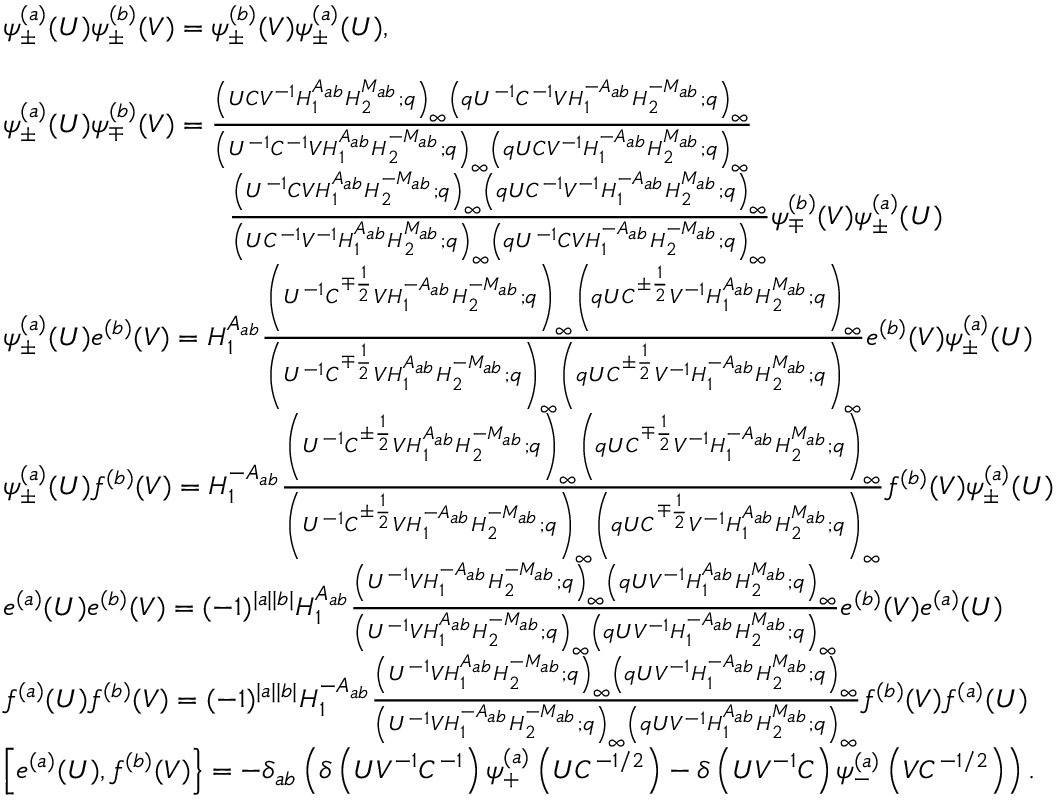Convert formula to latex. <formula><loc_0><loc_0><loc_500><loc_500>\begin{array} { r l } & { \psi _ { \pm } ^ { ( a ) } ( U ) \psi _ { \pm } ^ { ( b ) } ( V ) = \psi _ { \pm } ^ { ( b ) } ( V ) \psi _ { \pm } ^ { ( a ) } ( U ) , } \\ \\ & { \psi _ { \pm } ^ { ( a ) } ( U ) \psi _ { \mp } ^ { ( b ) } ( V ) = \frac { \left ( U C V ^ { - 1 } H _ { 1 } ^ { A _ { a b } } H _ { 2 } ^ { M _ { a b } } ; q \right ) _ { \infty } \left ( q U ^ { - 1 } C ^ { - 1 } V H _ { 1 } ^ { - A _ { a b } } H _ { 2 } ^ { - M _ { a b } } ; q \right ) _ { \infty } } { \left ( U ^ { - 1 } C ^ { - 1 } V H _ { 1 } ^ { A _ { a b } } H _ { 2 } ^ { - M _ { a b } } ; q \right ) _ { \infty } \left ( q U C V ^ { - 1 } H _ { 1 } ^ { - A _ { a b } } H _ { 2 } ^ { M _ { a b } } ; q \right ) _ { \infty } } } \\ & { \quad \frac { \left ( U ^ { - 1 } C V H _ { 1 } ^ { A _ { a b } } H _ { 2 } ^ { - M _ { a b } } ; q \right ) _ { \infty } \left ( q U C ^ { - 1 } V ^ { - 1 } H _ { 1 } ^ { - A _ { a b } } H _ { 2 } ^ { M _ { a b } } ; q \right ) _ { \infty } } { \left ( U C ^ { - 1 } V ^ { - 1 } H _ { 1 } ^ { A _ { a b } } H _ { 2 } ^ { M _ { a b } } ; q \right ) _ { \infty } \left ( q U ^ { - 1 } C V H _ { 1 } ^ { - A _ { a b } } H _ { 2 } ^ { - M _ { a b } } ; q \right ) _ { \infty } } \psi _ { \mp } ^ { ( b ) } ( V ) \psi _ { \pm } ^ { ( a ) } ( U ) } \\ & { \psi _ { \pm } ^ { ( a ) } ( U ) e ^ { ( b ) } ( V ) = H _ { 1 } ^ { A _ { a b } } \frac { \left ( U ^ { - 1 } C ^ { \mp \frac { 1 } { 2 } } V H _ { 1 } ^ { - A _ { a b } } H _ { 2 } ^ { - M _ { a b } } ; q \right ) _ { \infty } \left ( q U C ^ { \pm \frac { 1 } { 2 } } V ^ { - 1 } H _ { 1 } ^ { A _ { a b } } H _ { 2 } ^ { M _ { a b } } ; q \right ) _ { \infty } } { \left ( U ^ { - 1 } C ^ { \mp \frac { 1 } { 2 } } V H _ { 1 } ^ { A _ { a b } } H _ { 2 } ^ { - M _ { a b } } ; q \right ) _ { \infty } \left ( q U C ^ { \pm \frac { 1 } { 2 } } V ^ { - 1 } H _ { 1 } ^ { - A _ { a b } } H _ { 2 } ^ { M _ { a b } } ; q \right ) _ { \infty } } e ^ { ( b ) } ( V ) \psi _ { \pm } ^ { ( a ) } ( U ) } \\ & { \psi _ { \pm } ^ { ( a ) } ( U ) f ^ { ( b ) } ( V ) = H _ { 1 } ^ { - A _ { a b } } \frac { \left ( U ^ { - 1 } C ^ { \pm \frac { 1 } { 2 } } V H _ { 1 } ^ { A _ { a b } } H _ { 2 } ^ { - M _ { a b } } ; q \right ) _ { \infty } \left ( q U C ^ { \mp \frac { 1 } { 2 } } V ^ { - 1 } H _ { 1 } ^ { - A _ { a b } } H _ { 2 } ^ { M _ { a b } } ; q \right ) _ { \infty } } { \left ( U ^ { - 1 } C ^ { \pm \frac { 1 } { 2 } } V H _ { 1 } ^ { - A _ { a b } } H _ { 2 } ^ { - M _ { a b } } ; q \right ) _ { \infty } \left ( q U C ^ { \mp \frac { 1 } { 2 } } V ^ { - 1 } H _ { 1 } ^ { A _ { a b } } H _ { 2 } ^ { M _ { a b } } ; q \right ) _ { \infty } } f ^ { ( b ) } ( V ) \psi _ { \pm } ^ { ( a ) } ( U ) } \\ & { e ^ { ( a ) } ( U ) e ^ { ( b ) } ( V ) = ( - 1 ) ^ { | a | | b | } H _ { 1 } ^ { A _ { a b } } \frac { \left ( U ^ { - 1 } V H _ { 1 } ^ { - A _ { a b } } H _ { 2 } ^ { - M _ { a b } } ; q \right ) _ { \infty } \left ( q U V ^ { - 1 } H _ { 1 } ^ { A _ { a b } } H _ { 2 } ^ { M _ { a b } } ; q \right ) _ { \infty } } { \left ( U ^ { - 1 } V H _ { 1 } ^ { A _ { a b } } H _ { 2 } ^ { - M _ { a b } } ; q \right ) _ { \infty } \left ( q U V ^ { - 1 } H _ { 1 } ^ { - A _ { a b } } H _ { 2 } ^ { M _ { a b } } ; q \right ) _ { \infty } } e ^ { ( b ) } ( V ) e ^ { ( a ) } ( U ) } \\ & { f ^ { ( a ) } ( U ) f ^ { ( b ) } ( V ) = ( - 1 ) ^ { | a | | b | } H _ { 1 } ^ { - A _ { a b } } \frac { \left ( U ^ { - 1 } V H _ { 1 } ^ { A _ { a b } } H _ { 2 } ^ { - M _ { a b } } ; q \right ) _ { \infty } \left ( q U V ^ { - 1 } H _ { 1 } ^ { - A _ { a b } } H _ { 2 } ^ { M _ { a b } } ; q \right ) _ { \infty } } { \left ( U ^ { - 1 } V H _ { 1 } ^ { - A _ { a b } } H _ { 2 } ^ { - M _ { a b } } ; q \right ) _ { \infty } \left ( q U V ^ { - 1 } H _ { 1 } ^ { A _ { a b } } H _ { 2 } ^ { M _ { a b } } ; q \right ) _ { \infty } } f ^ { ( b ) } ( V ) f ^ { ( a ) } ( U ) } \\ & { \left [ e ^ { ( a ) } ( U ) , f ^ { ( b ) } ( V ) \right \} = - \delta _ { a b } \left ( \delta \left ( U V ^ { - 1 } C ^ { - 1 } \right ) \psi _ { + } ^ { ( a ) } \left ( U C ^ { - 1 / 2 } \right ) - \delta \left ( U V ^ { - 1 } C \right ) \psi _ { - } ^ { ( a ) } \left ( V C ^ { - 1 / 2 } \right ) \right ) . } \end{array}</formula> 